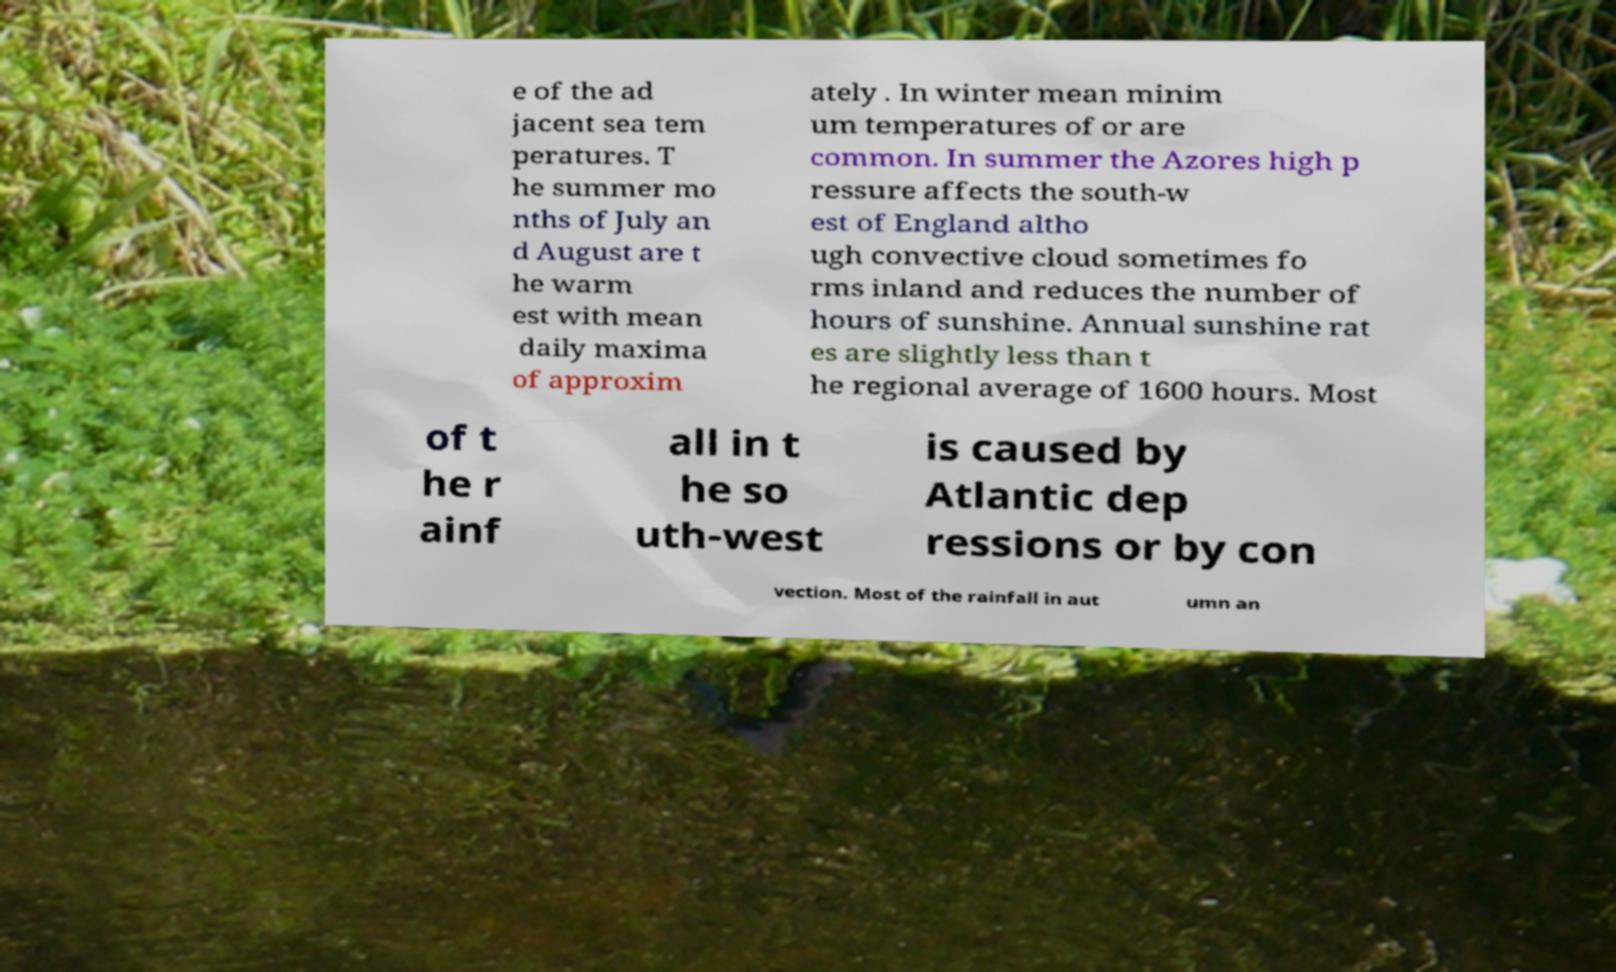What messages or text are displayed in this image? I need them in a readable, typed format. e of the ad jacent sea tem peratures. T he summer mo nths of July an d August are t he warm est with mean daily maxima of approxim ately . In winter mean minim um temperatures of or are common. In summer the Azores high p ressure affects the south-w est of England altho ugh convective cloud sometimes fo rms inland and reduces the number of hours of sunshine. Annual sunshine rat es are slightly less than t he regional average of 1600 hours. Most of t he r ainf all in t he so uth-west is caused by Atlantic dep ressions or by con vection. Most of the rainfall in aut umn an 